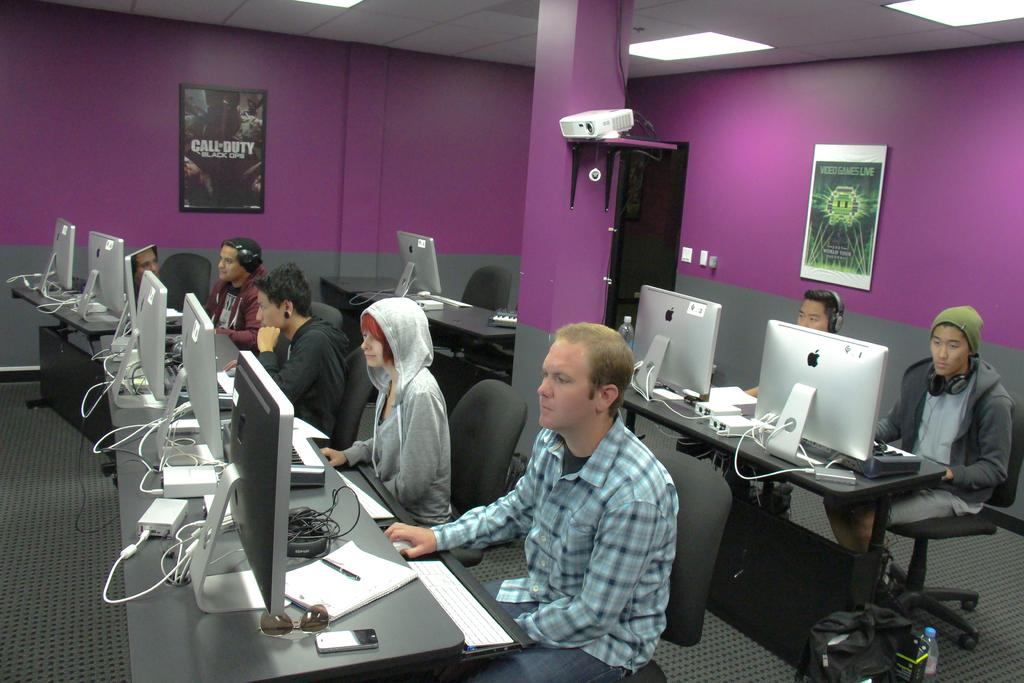<image>
Present a compact description of the photo's key features. Several people sitting at PCs with a Call of Duty poster on the wall. 